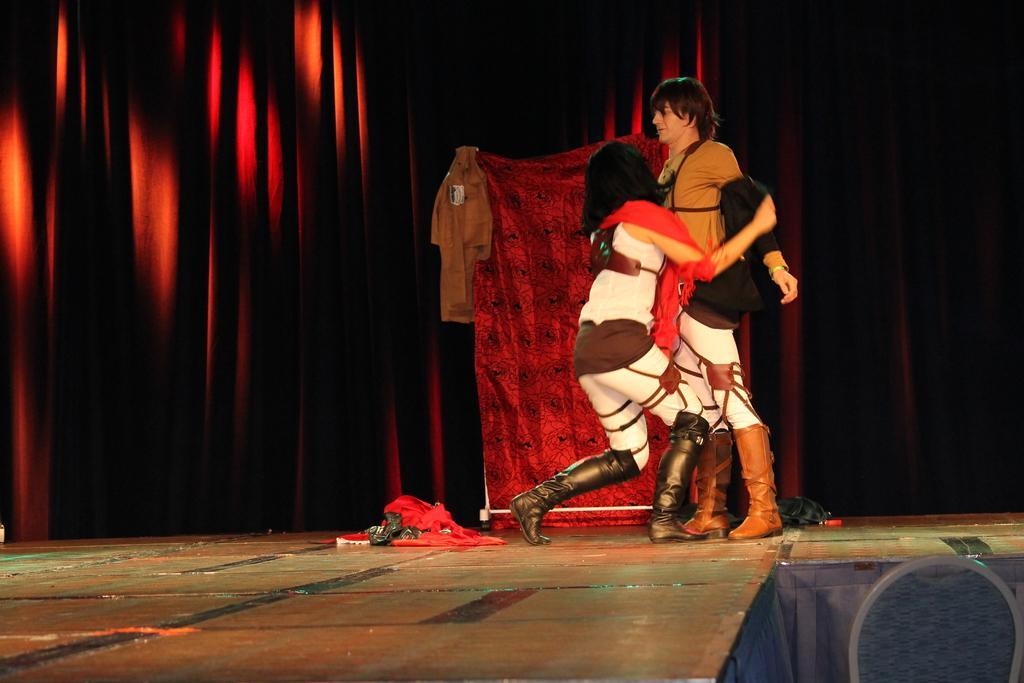Please provide a concise description of this image. The girl in white dress and the man in brown T-shirt are standing on the stage. Beside her, we see a red color cloth is on the stage. They might be performing the drama. Behind them, we see a red color cloth. On the left side, we see a maroon sheet. On the right side, it is black in color. 